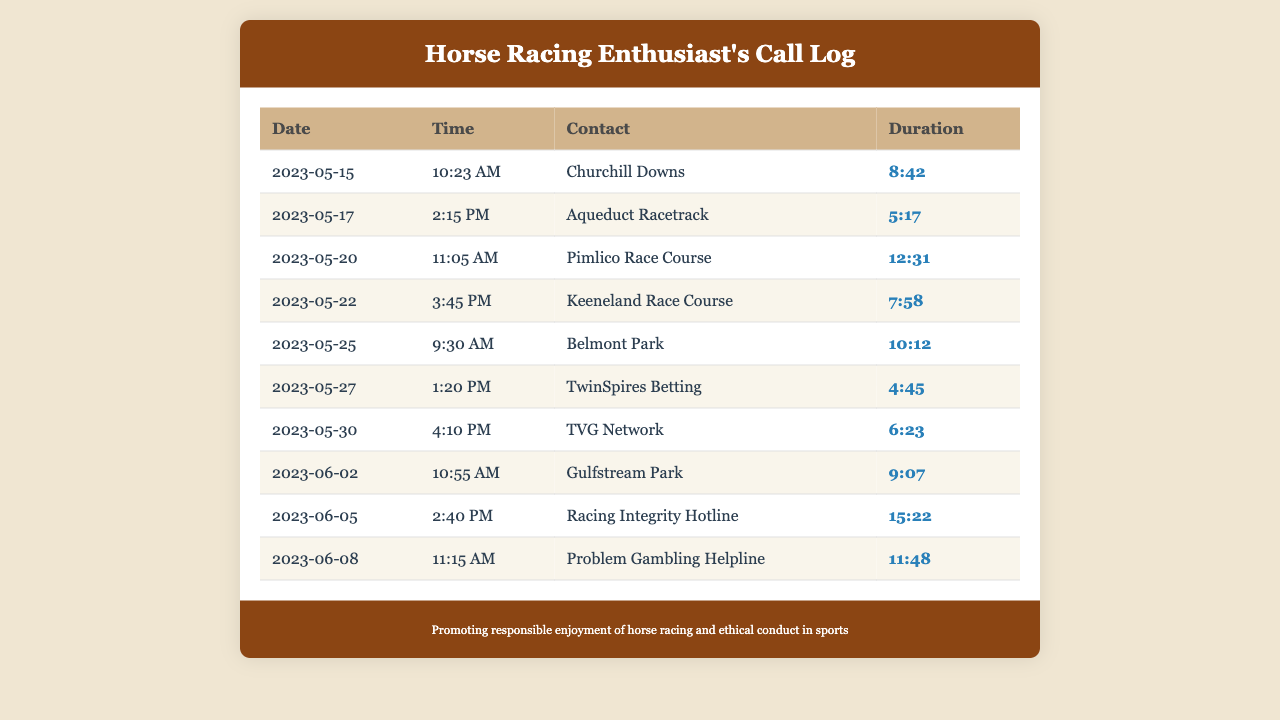What is the first contact in the call log? The first contact listed in the table is on the date of May 15, 2023, at 10:23 AM.
Answer: Churchill Downs How long was the call to Keeneland Race Course? The duration of the call to Keeneland Race Course is displayed in the log and is found in the respective row for that contact.
Answer: 7:58 How many times was TwinSpires Betting contacted? The document lists contacts, and by counting, the number of times TwinSpires Betting appears gives this count.
Answer: 1 What was the last date of the calls recorded? The last date recorded in the call log entries is shown at the bottom of the table.
Answer: June 8, 2023 What is the longest call duration in the log? To identify the longest call duration, you look for the maximum value in the duration column.
Answer: 15:22 Which helpline was called on June 8, 2023? The specific helpline is indicated in the log under the contact entry for the date of June 8, 2023.
Answer: Problem Gambling Helpline Which racetrack was called on May 20, 2023? The racetrack is evident from the date and the respective contact for that entry in the log.
Answer: Pimlico Race Course What time was the call to Aqueduct Racetrack made? The time of the call is noted next to the respective date for Aqueduct Racetrack in the call log.
Answer: 2:15 PM How many unique racing locations are listed in the call log? Counting the unique entries in the contact column of the log reveals the answer.
Answer: 8 